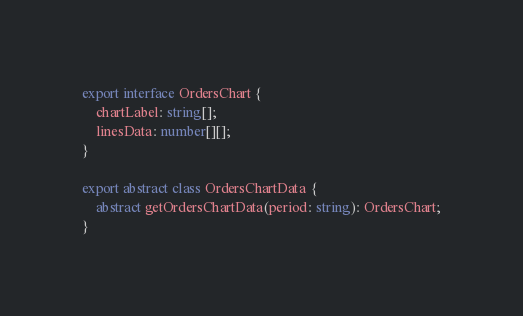Convert code to text. <code><loc_0><loc_0><loc_500><loc_500><_TypeScript_>export interface OrdersChart {
	chartLabel: string[];
	linesData: number[][];
}

export abstract class OrdersChartData {
	abstract getOrdersChartData(period: string): OrdersChart;
}
</code> 